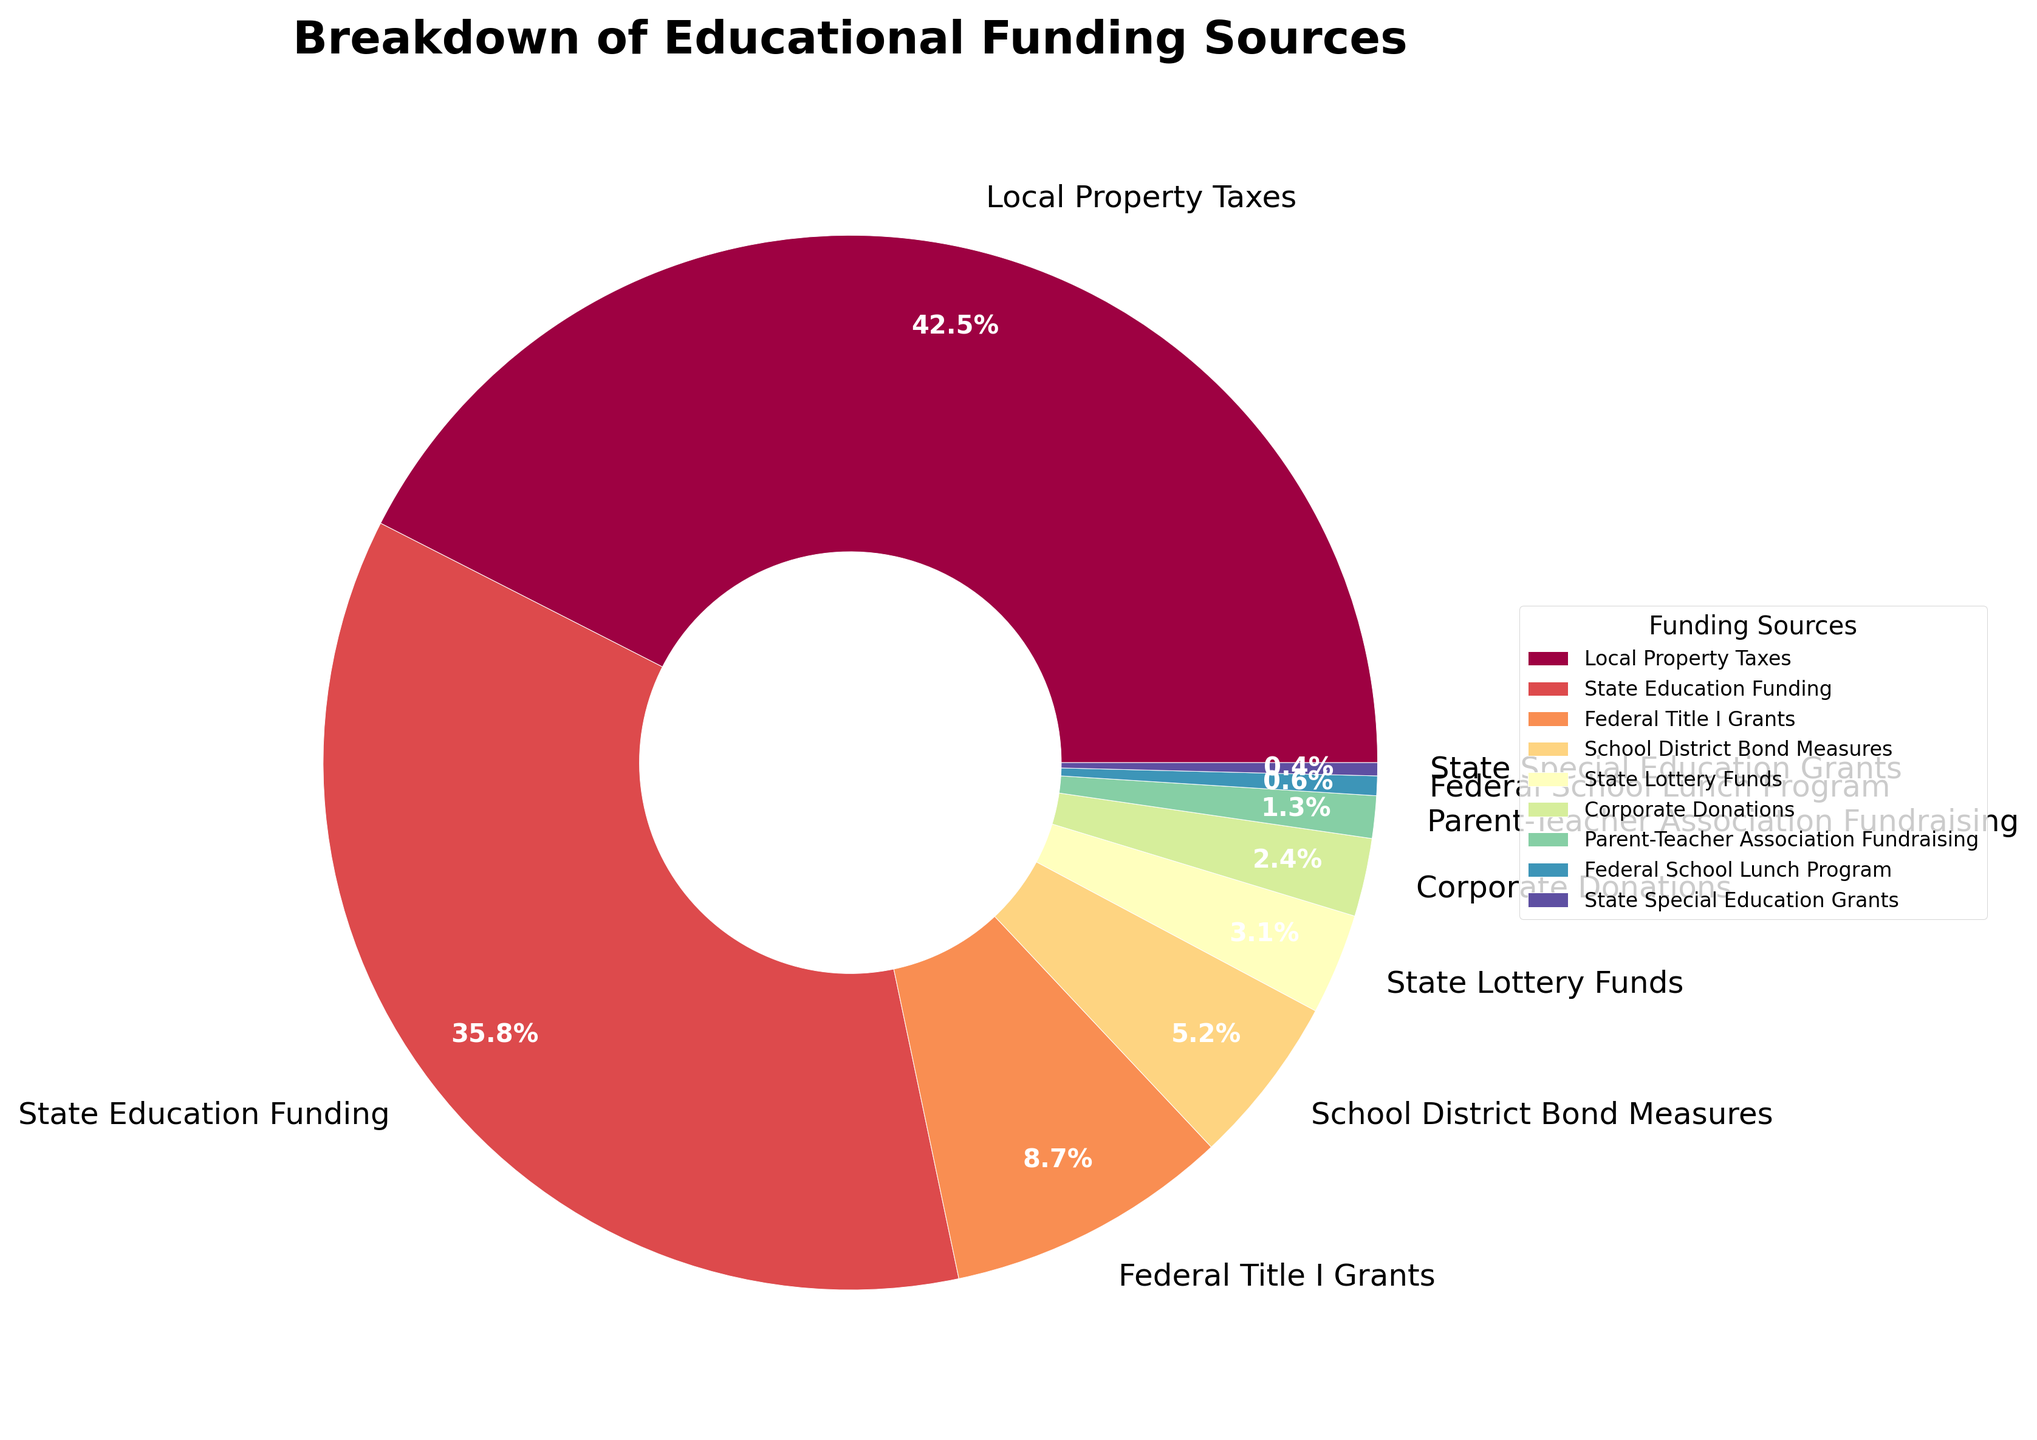Which funding source contributes the highest percentage of educational funding? From the pie chart, the largest slice represents Local Property Taxes at 42.5%.
Answer: Local Property Taxes Which funding source contributes less than 1% to educational funding? The chart shows that Federal School Lunch Program and State Special Education Grants have contributions less than 1%, specifically 0.6% and 0.4%, respectively.
Answer: Federal School Lunch Program and State Special Education Grants What is the total percentage contribution from federal funding sources? The federal funding sources are Federal Title I Grants (8.7%) and Federal School Lunch Program (0.6%). Adding these two: 8.7% + 0.6% = 9.3%.
Answer: 9.3% Which source has a smaller percentage, Corporate Donations or Parent-Teacher Association Fundraising, and by how much? Corporate Donations account for 2.4%, while Parent-Teacher Association Fundraising accounts for 1.3%. The difference is 2.4% - 1.3% = 1.1%.
Answer: Parent-Teacher Association Fundraising by 1.1% What is the combined contribution from State Education Funding and State Lottery Funds? State Education Funding is 35.8% and State Lottery Funds are 3.1%. Adding these two: 35.8% + 3.1% = 38.9%.
Answer: 38.9% By how much does Local Property Taxes' contribution surpass State Education Funding? Local Property Taxes contribute 42.5%, while State Education Funding contributes 35.8%. The difference is 42.5% - 35.8% = 6.7%.
Answer: 6.7% Which three sources have the smallest contributions and what are their combined percentage? The three smallest contributions come from Parent-Teacher Association Fundraising (1.3%), Federal School Lunch Program (0.6%), and State Special Education Grants (0.4%). Their combined percentage is 1.3% + 0.6% + 0.4% = 2.3%.
Answer: 2.3% Which funding sources together make up less than 10% of the total funding? Contributions from Federal Title I Grants (8.7%), School District Bond Measures (5.2%), State Lottery Funds (3.1%), Corporate Donations (2.4%), Parent-Teacher Association Fundraising (1.3%), Federal School Lunch Program (0.6%), and State Special Education Grants (0.4%). Summing the smallest contributions until total is less than 10%: Corporate Donations (2.4%) + Parent-Teacher Association Fundraising (1.3%) + Federal School Lunch Program (0.6%) + State Special Education Grants (0.4%) = 4.7%.
Answer: Corporate Donations, Parent-Teacher Association Fundraising, Federal School Lunch Program, State Special Education Grants Which funding sources contribute more than 5% each? From the chart, Local Property Taxes (42.5%), State Education Funding (35.8%), and School District Bond Measures (5.2%) each contribute more than 5%.
Answer: Local Property Taxes, State Education Funding, School District Bond Measures 